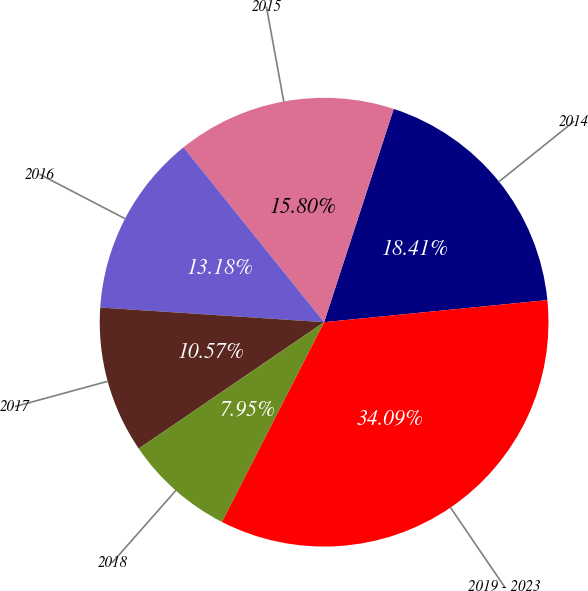Convert chart to OTSL. <chart><loc_0><loc_0><loc_500><loc_500><pie_chart><fcel>2014<fcel>2015<fcel>2016<fcel>2017<fcel>2018<fcel>2019 - 2023<nl><fcel>18.41%<fcel>15.8%<fcel>13.18%<fcel>10.57%<fcel>7.95%<fcel>34.09%<nl></chart> 